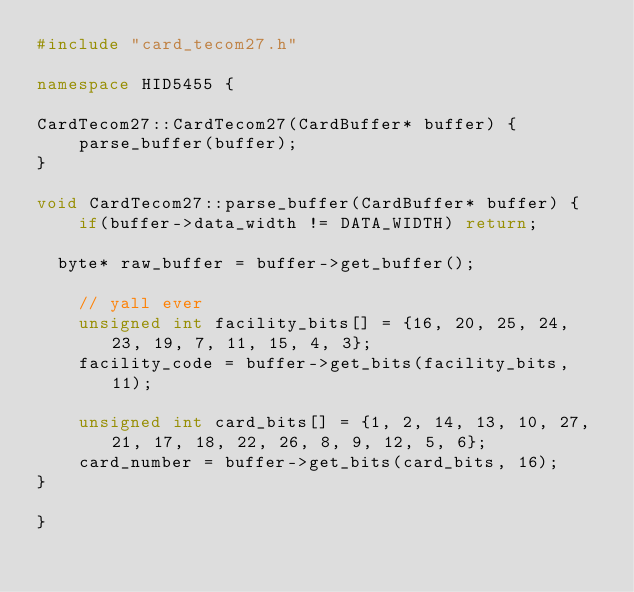<code> <loc_0><loc_0><loc_500><loc_500><_C++_>#include "card_tecom27.h"

namespace HID5455 {

CardTecom27::CardTecom27(CardBuffer* buffer) {
    parse_buffer(buffer);
}

void CardTecom27::parse_buffer(CardBuffer* buffer) {
    if(buffer->data_width != DATA_WIDTH) return;

	byte* raw_buffer = buffer->get_buffer();

    // yall ever
    unsigned int facility_bits[] = {16, 20, 25, 24, 23, 19, 7, 11, 15, 4, 3};
    facility_code = buffer->get_bits(facility_bits, 11);

    unsigned int card_bits[] = {1, 2, 14, 13, 10, 27, 21, 17, 18, 22, 26, 8, 9, 12, 5, 6};
    card_number = buffer->get_bits(card_bits, 16);
}

}</code> 